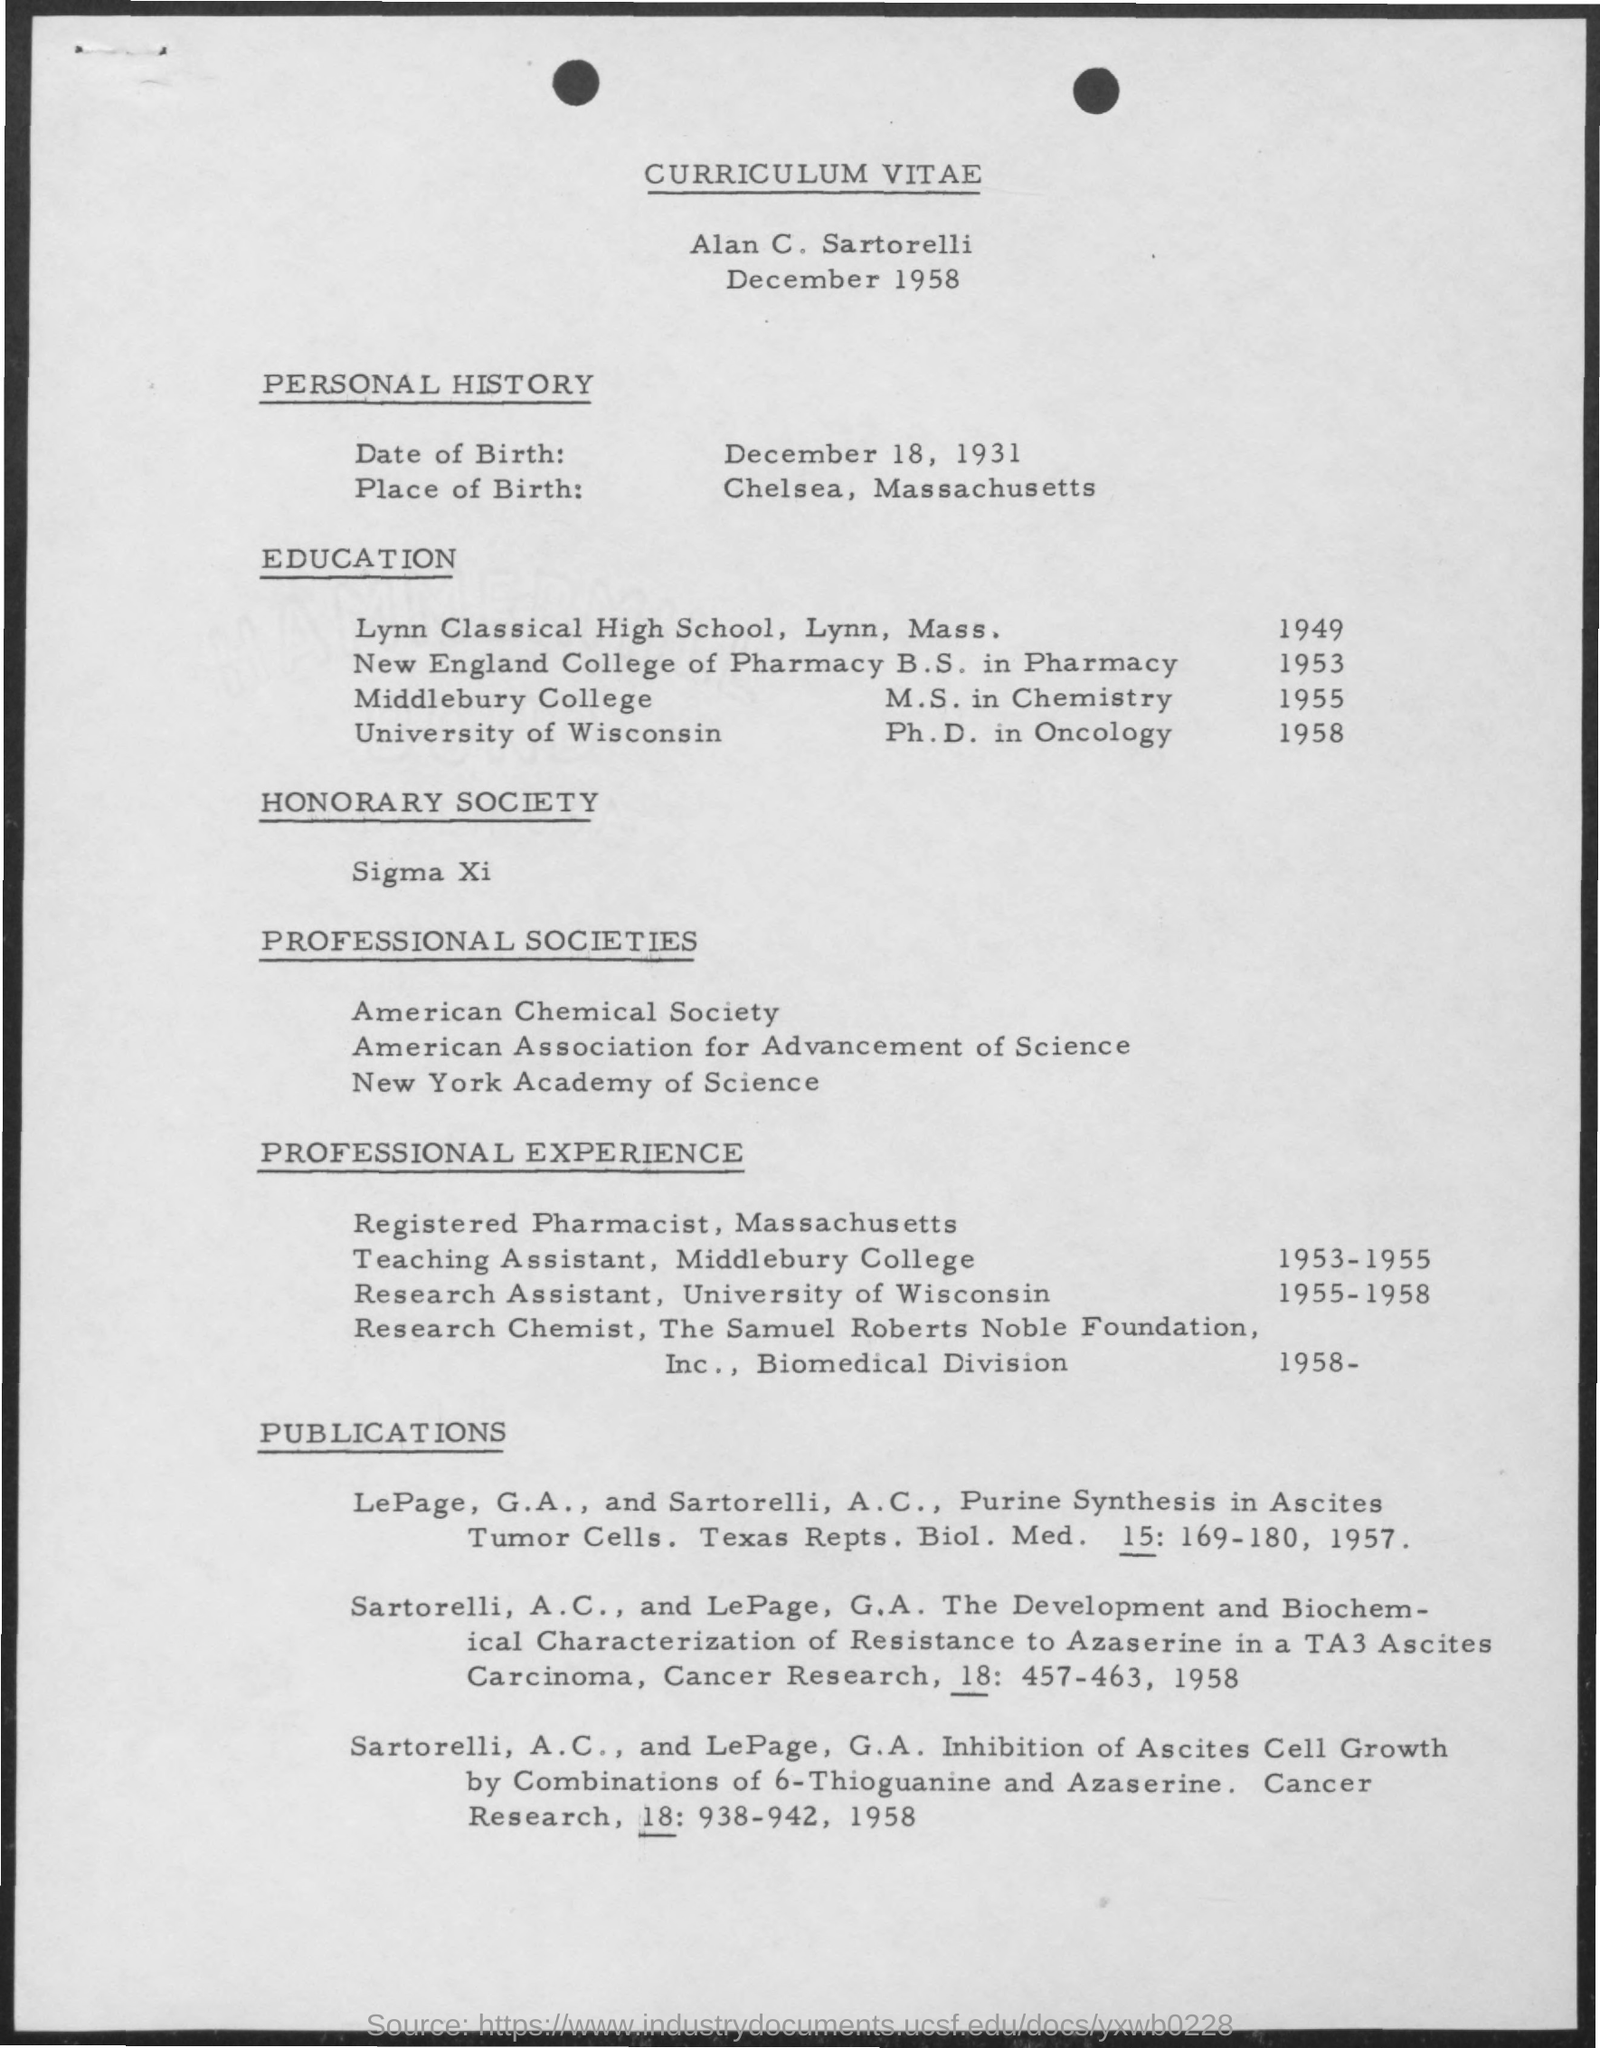Outline some significant characteristics in this image. Alan C. Sartorelli completed his Master of Science in Chemistry at Middlebury College in 1955. Alan C. Sartorelli worked as a Research Assistant at the University of Wisconsin from 1955 to 1958. Alan C. Sartorelli's date of birth is December 18, 1931. Alan C. Sartorelli worked as a Teaching Assistant at Middlebury College from 1953 to 1955. Alan C. Sartorelli completed his B.S. in Pharmacy at New England College of Pharmacy. 